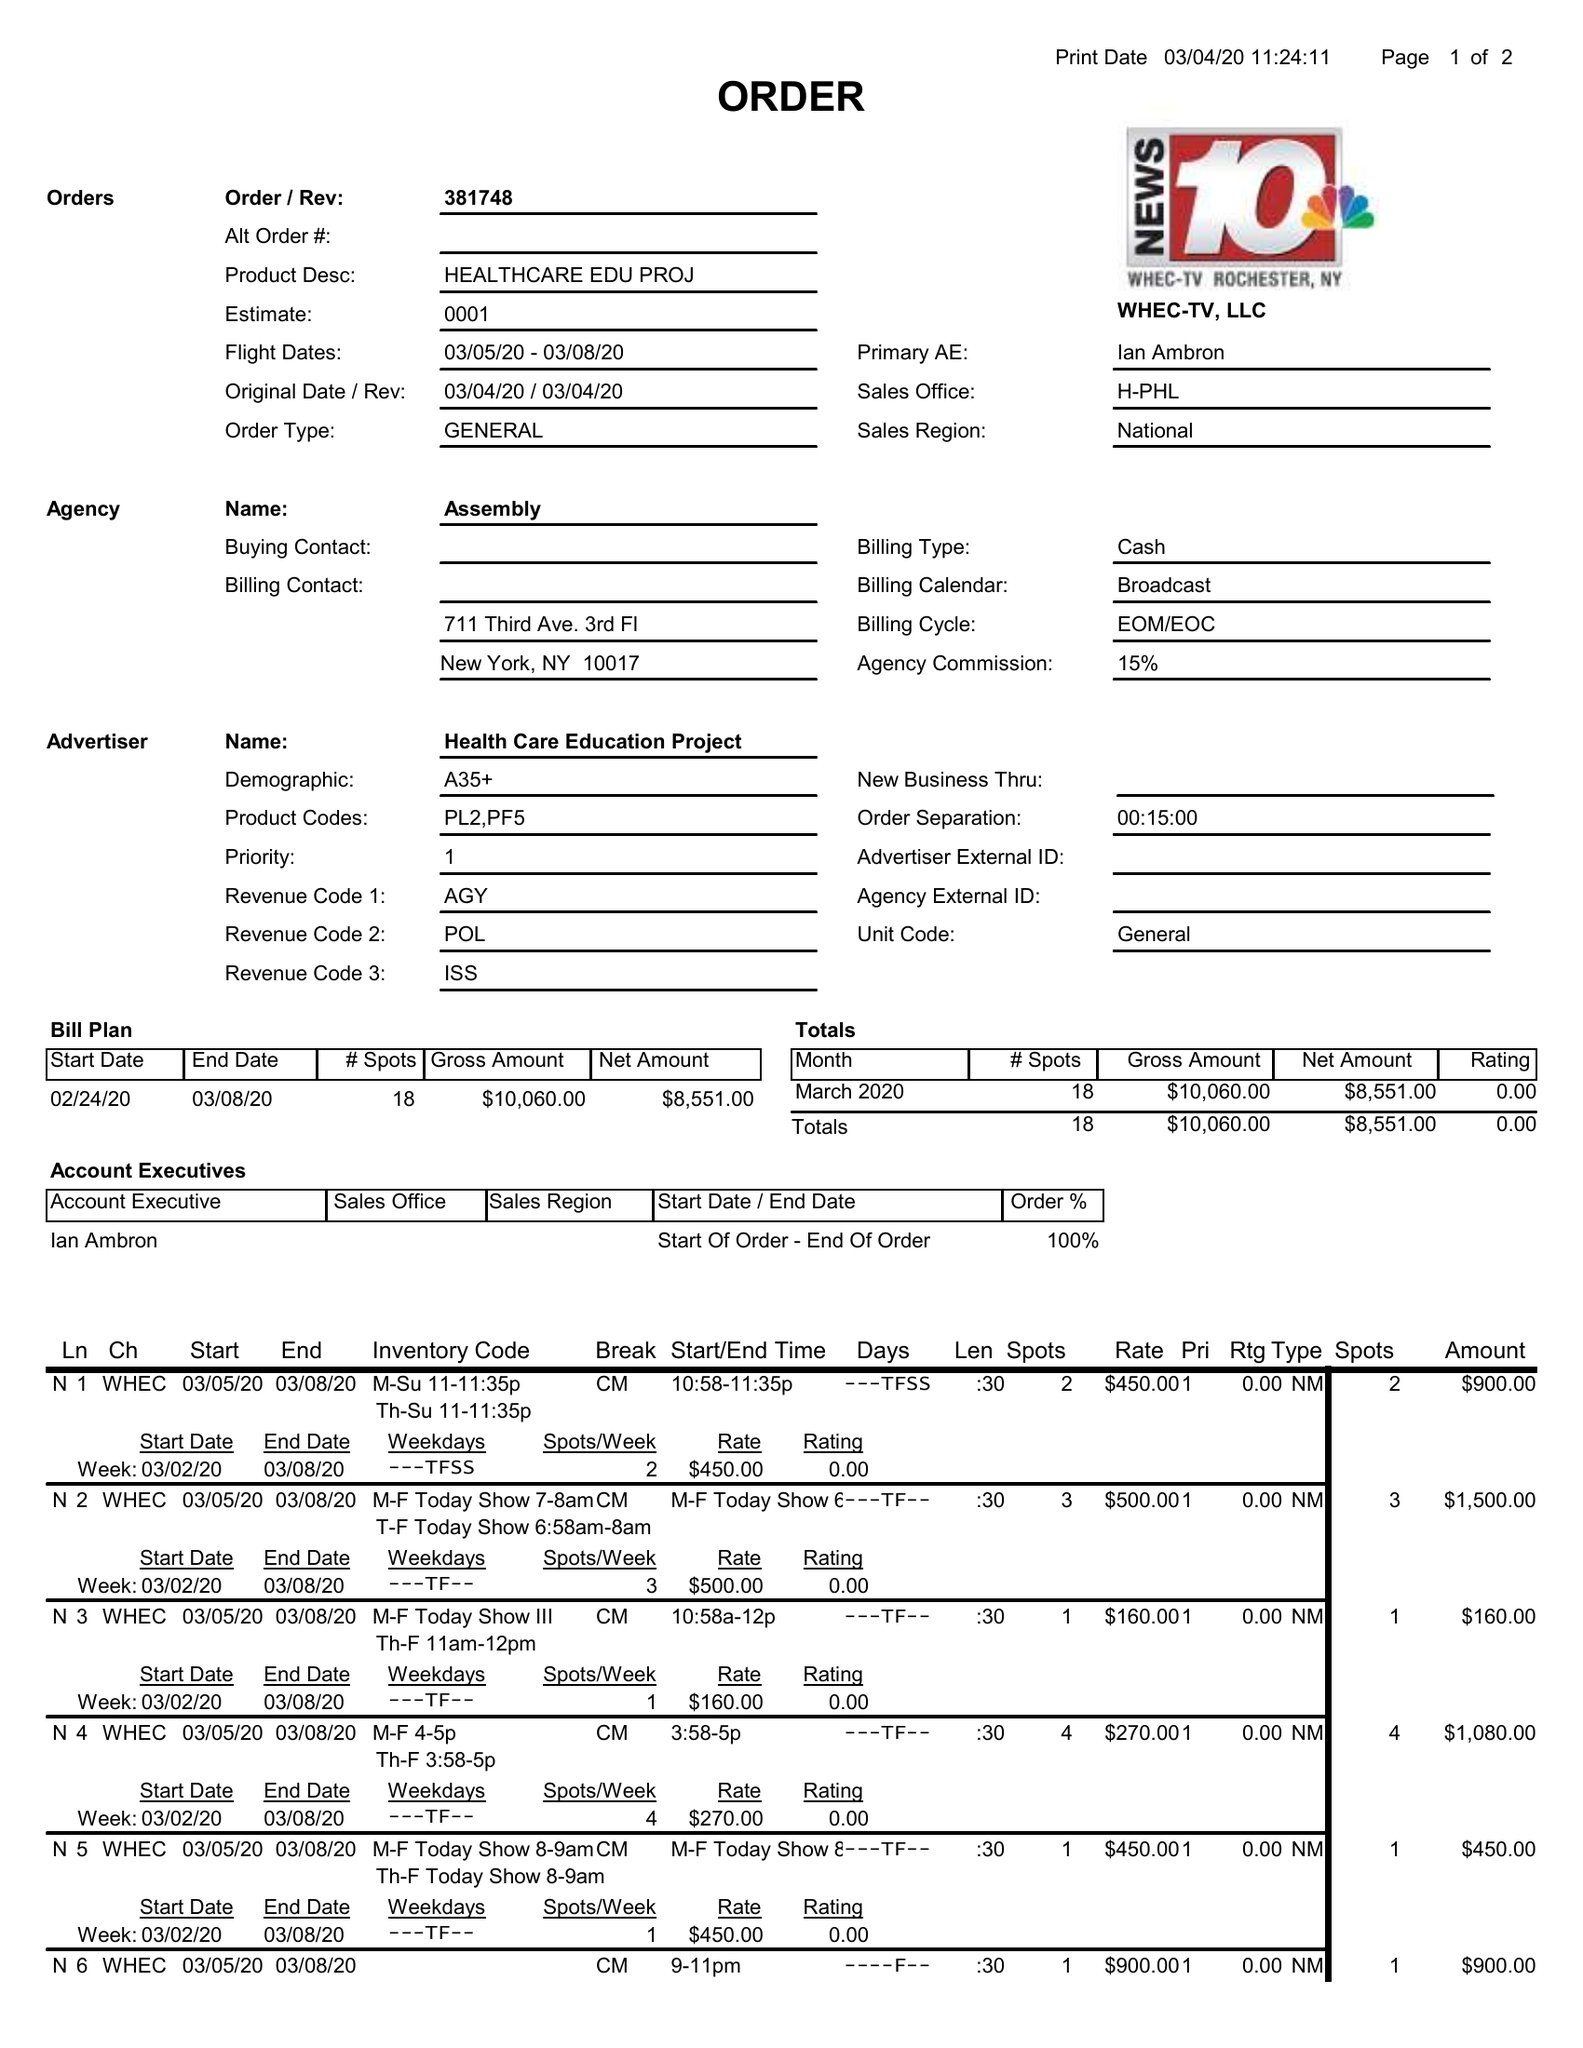What is the value for the advertiser?
Answer the question using a single word or phrase. HEALTH CARE EDUCATION PROJECT 